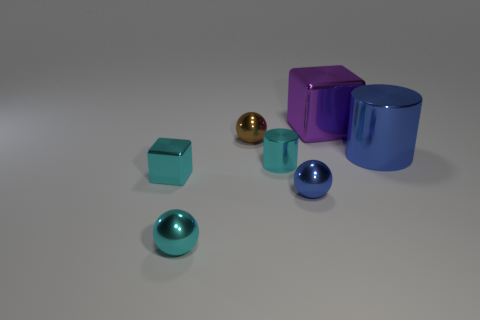Add 3 small shiny cylinders. How many objects exist? 10 Subtract all cubes. How many objects are left? 5 Subtract 0 yellow blocks. How many objects are left? 7 Subtract all big things. Subtract all blue metal objects. How many objects are left? 3 Add 5 small brown metal things. How many small brown metal things are left? 6 Add 1 red cylinders. How many red cylinders exist? 1 